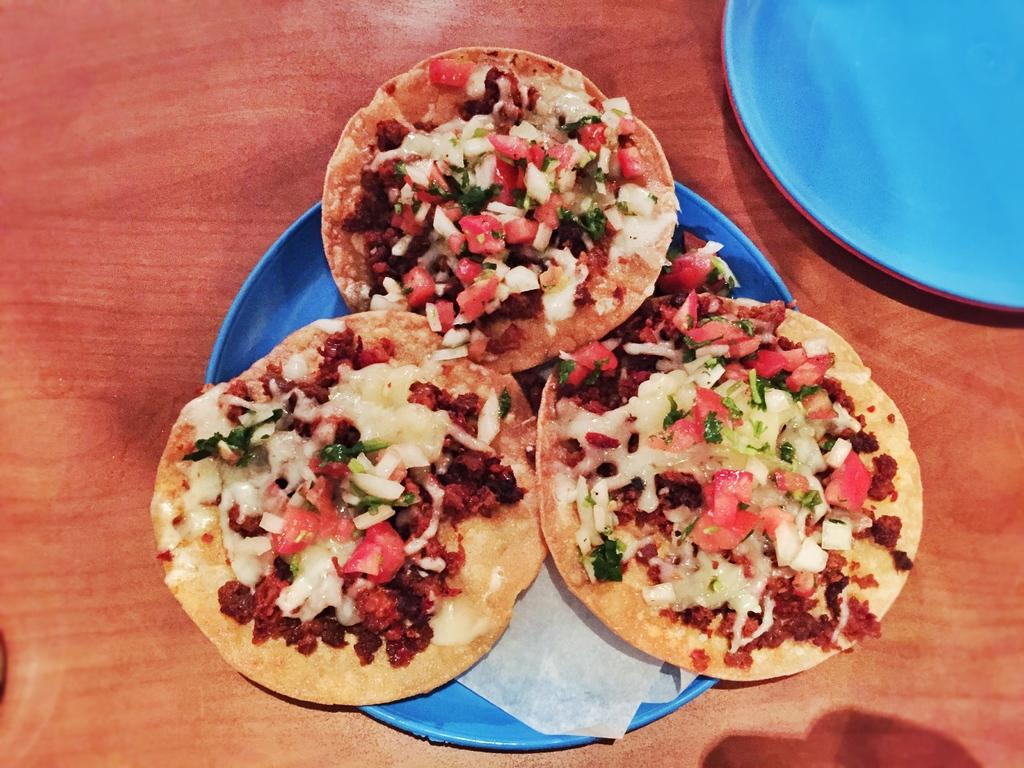What is placed on the blue color plate in the image? There are eatables placed on a blue color plate in the image. Can you describe the other plates in the image? There are two other plates in the right top corner of the image. What type of dog can be seen interacting with the fireman in the image? There is no dog or fireman present in the image; it only features plates with eatables. 